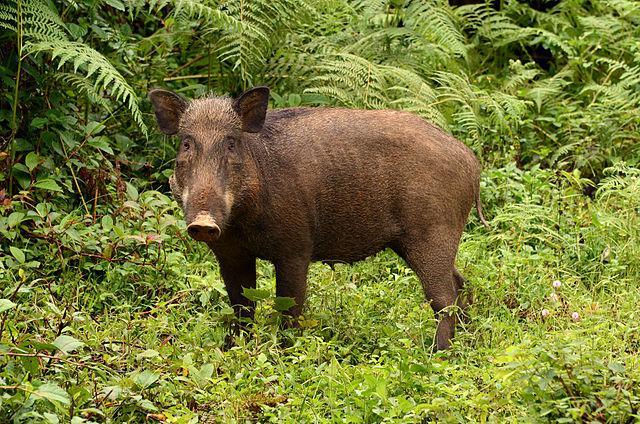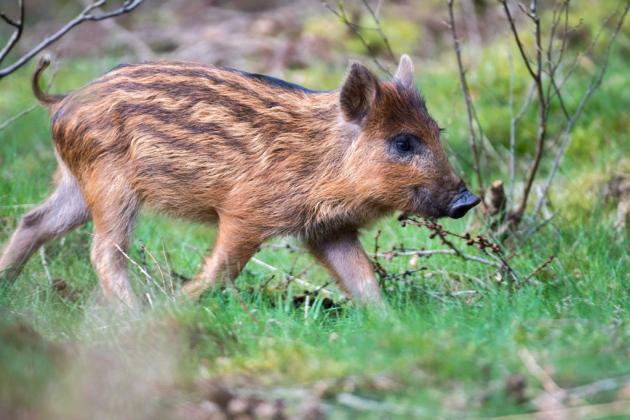The first image is the image on the left, the second image is the image on the right. Evaluate the accuracy of this statement regarding the images: "Both images show the same number of baby warthogs.". Is it true? Answer yes or no. No. 